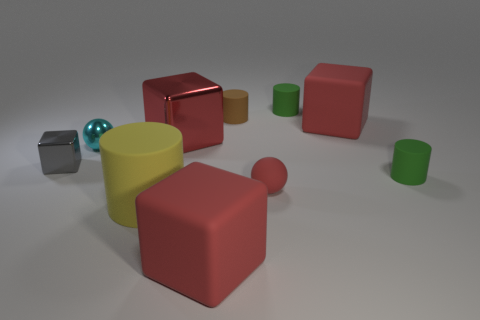Subtract all gray metal cubes. How many cubes are left? 3 Subtract all yellow spheres. How many red cubes are left? 3 Subtract all yellow cylinders. How many cylinders are left? 3 Subtract 1 spheres. How many spheres are left? 1 Subtract all balls. How many objects are left? 8 Add 4 small cyan spheres. How many small cyan spheres exist? 5 Subtract 0 brown balls. How many objects are left? 10 Subtract all brown cylinders. Subtract all gray blocks. How many cylinders are left? 3 Subtract all tiny things. Subtract all tiny blue cylinders. How many objects are left? 4 Add 8 tiny matte balls. How many tiny matte balls are left? 9 